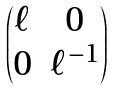<formula> <loc_0><loc_0><loc_500><loc_500>\begin{pmatrix} \ell & 0 \\ 0 & \ell ^ { - 1 } \end{pmatrix}</formula> 